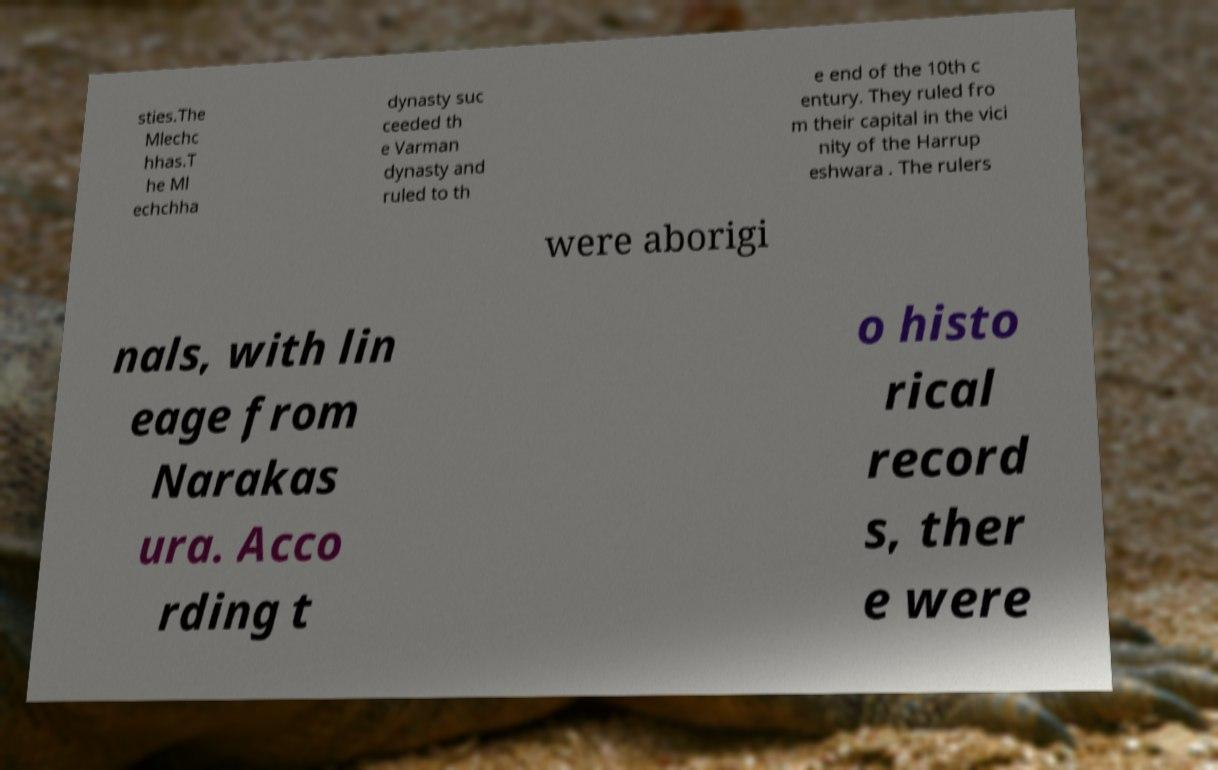Could you assist in decoding the text presented in this image and type it out clearly? sties.The Mlechc hhas.T he Ml echchha dynasty suc ceeded th e Varman dynasty and ruled to th e end of the 10th c entury. They ruled fro m their capital in the vici nity of the Harrup eshwara . The rulers were aborigi nals, with lin eage from Narakas ura. Acco rding t o histo rical record s, ther e were 